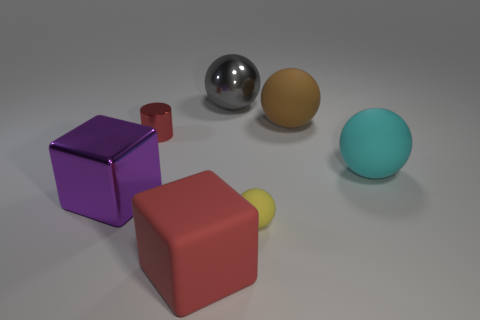Is there any other thing of the same color as the metallic cylinder?
Keep it short and to the point. Yes. What is the shape of the big brown rubber thing?
Make the answer very short. Sphere. What number of large rubber things are behind the big purple shiny object and in front of the red shiny cylinder?
Provide a succinct answer. 1. Is the metal cylinder the same color as the large matte block?
Your answer should be very brief. Yes. There is a gray thing that is the same shape as the brown thing; what is its material?
Make the answer very short. Metal. Are there an equal number of tiny cylinders that are in front of the metal cylinder and large matte things behind the cyan matte object?
Your answer should be compact. No. Does the brown object have the same material as the purple cube?
Your response must be concise. No. How many yellow things are metallic cylinders or metallic blocks?
Your answer should be very brief. 0. What number of large purple shiny objects have the same shape as the red rubber object?
Your answer should be compact. 1. What is the big purple thing made of?
Provide a succinct answer. Metal. 